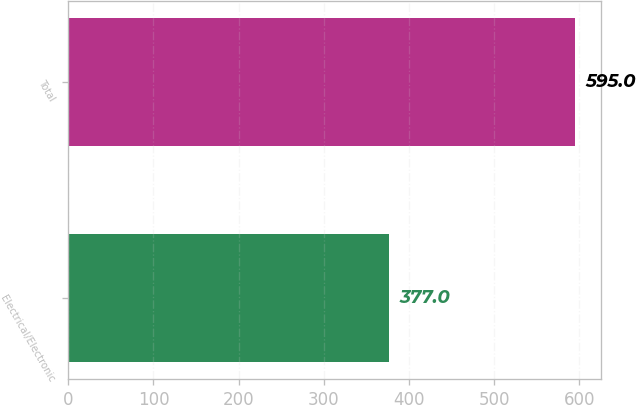Convert chart to OTSL. <chart><loc_0><loc_0><loc_500><loc_500><bar_chart><fcel>Electrical/Electronic<fcel>Total<nl><fcel>377<fcel>595<nl></chart> 